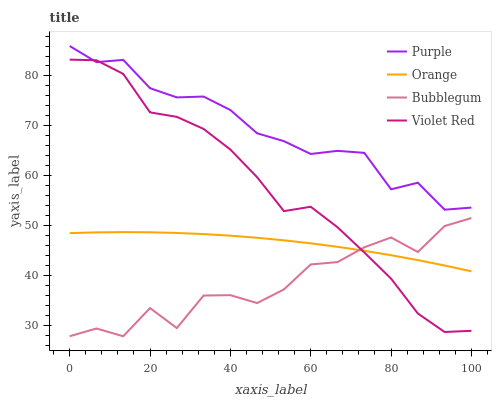Does Bubblegum have the minimum area under the curve?
Answer yes or no. Yes. Does Purple have the maximum area under the curve?
Answer yes or no. Yes. Does Orange have the minimum area under the curve?
Answer yes or no. No. Does Orange have the maximum area under the curve?
Answer yes or no. No. Is Orange the smoothest?
Answer yes or no. Yes. Is Bubblegum the roughest?
Answer yes or no. Yes. Is Violet Red the smoothest?
Answer yes or no. No. Is Violet Red the roughest?
Answer yes or no. No. Does Bubblegum have the lowest value?
Answer yes or no. Yes. Does Orange have the lowest value?
Answer yes or no. No. Does Purple have the highest value?
Answer yes or no. Yes. Does Violet Red have the highest value?
Answer yes or no. No. Is Orange less than Purple?
Answer yes or no. Yes. Is Purple greater than Orange?
Answer yes or no. Yes. Does Orange intersect Bubblegum?
Answer yes or no. Yes. Is Orange less than Bubblegum?
Answer yes or no. No. Is Orange greater than Bubblegum?
Answer yes or no. No. Does Orange intersect Purple?
Answer yes or no. No. 